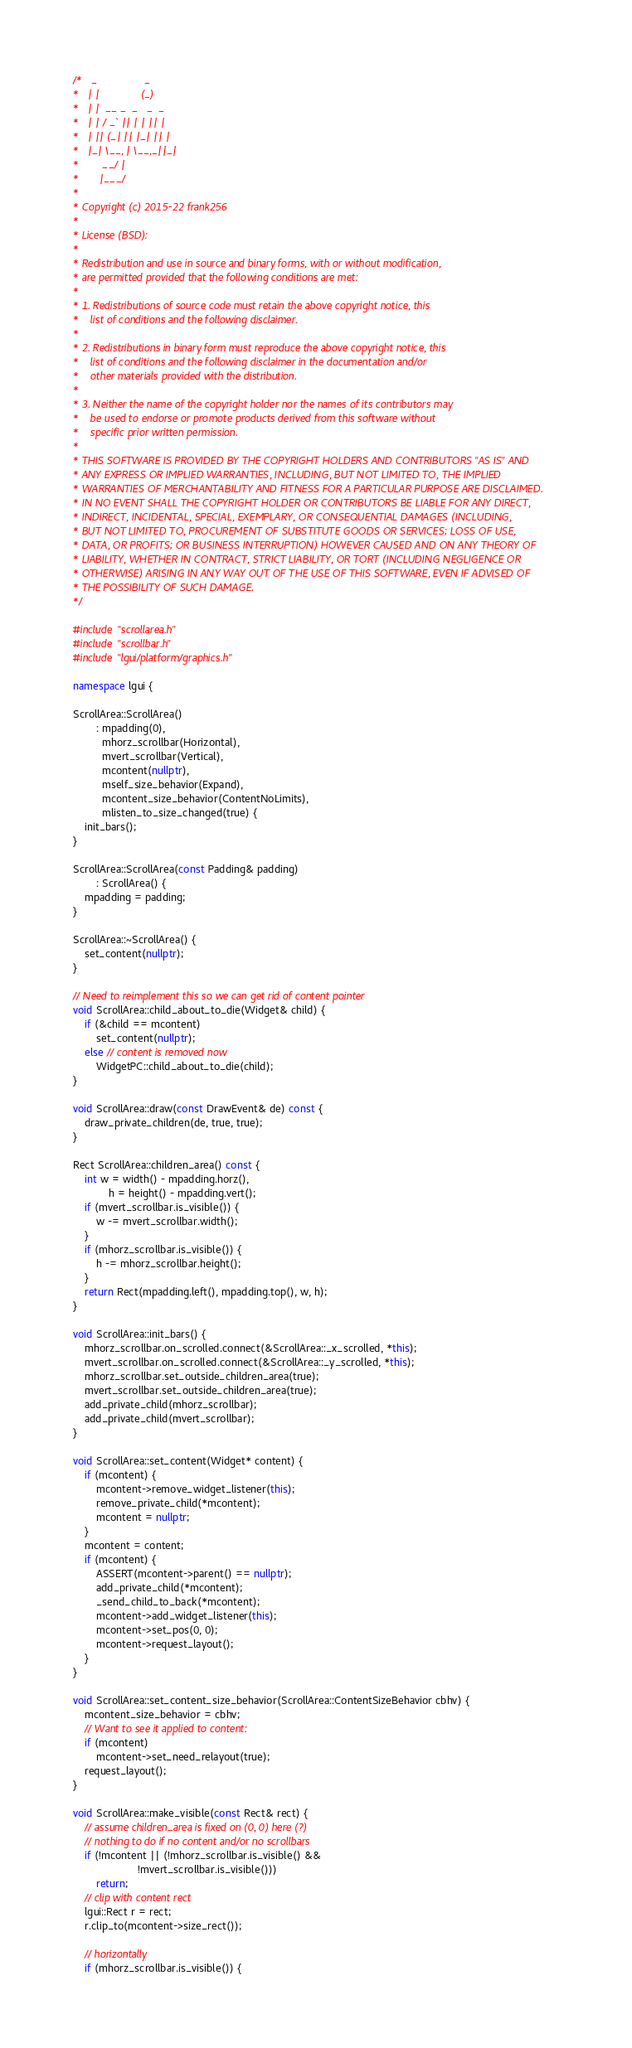<code> <loc_0><loc_0><loc_500><loc_500><_C++_>/*   _                _
*   | |              (_)
*   | |  __ _  _   _  _
*   | | / _` || | | || |
*   | || (_| || |_| || |
*   |_| \__, | \__,_||_|
*        __/ |
*       |___/
*
* Copyright (c) 2015-22 frank256
*
* License (BSD):
*
* Redistribution and use in source and binary forms, with or without modification,
* are permitted provided that the following conditions are met:
*
* 1. Redistributions of source code must retain the above copyright notice, this
*    list of conditions and the following disclaimer.
*
* 2. Redistributions in binary form must reproduce the above copyright notice, this
*    list of conditions and the following disclaimer in the documentation and/or
*    other materials provided with the distribution.
*
* 3. Neither the name of the copyright holder nor the names of its contributors may
*    be used to endorse or promote products derived from this software without
*    specific prior written permission.
*
* THIS SOFTWARE IS PROVIDED BY THE COPYRIGHT HOLDERS AND CONTRIBUTORS "AS IS" AND
* ANY EXPRESS OR IMPLIED WARRANTIES, INCLUDING, BUT NOT LIMITED TO, THE IMPLIED
* WARRANTIES OF MERCHANTABILITY AND FITNESS FOR A PARTICULAR PURPOSE ARE DISCLAIMED.
* IN NO EVENT SHALL THE COPYRIGHT HOLDER OR CONTRIBUTORS BE LIABLE FOR ANY DIRECT,
* INDIRECT, INCIDENTAL, SPECIAL, EXEMPLARY, OR CONSEQUENTIAL DAMAGES (INCLUDING,
* BUT NOT LIMITED TO, PROCUREMENT OF SUBSTITUTE GOODS OR SERVICES; LOSS OF USE,
* DATA, OR PROFITS; OR BUSINESS INTERRUPTION) HOWEVER CAUSED AND ON ANY THEORY OF
* LIABILITY, WHETHER IN CONTRACT, STRICT LIABILITY, OR TORT (INCLUDING NEGLIGENCE OR
* OTHERWISE) ARISING IN ANY WAY OUT OF THE USE OF THIS SOFTWARE, EVEN IF ADVISED OF
* THE POSSIBILITY OF SUCH DAMAGE.
*/

#include "scrollarea.h"
#include "scrollbar.h"
#include "lgui/platform/graphics.h"

namespace lgui {

ScrollArea::ScrollArea()
        : mpadding(0),
          mhorz_scrollbar(Horizontal),
          mvert_scrollbar(Vertical),
          mcontent(nullptr),
          mself_size_behavior(Expand),
          mcontent_size_behavior(ContentNoLimits),
          mlisten_to_size_changed(true) {
    init_bars();
}

ScrollArea::ScrollArea(const Padding& padding)
        : ScrollArea() {
    mpadding = padding;
}

ScrollArea::~ScrollArea() {
    set_content(nullptr);
}

// Need to reimplement this so we can get rid of content pointer
void ScrollArea::child_about_to_die(Widget& child) {
    if (&child == mcontent)
        set_content(nullptr);
    else // content is removed now
        WidgetPC::child_about_to_die(child);
}

void ScrollArea::draw(const DrawEvent& de) const {
    draw_private_children(de, true, true);
}

Rect ScrollArea::children_area() const {
    int w = width() - mpadding.horz(),
            h = height() - mpadding.vert();
    if (mvert_scrollbar.is_visible()) {
        w -= mvert_scrollbar.width();
    }
    if (mhorz_scrollbar.is_visible()) {
        h -= mhorz_scrollbar.height();
    }
    return Rect(mpadding.left(), mpadding.top(), w, h);
}

void ScrollArea::init_bars() {
    mhorz_scrollbar.on_scrolled.connect(&ScrollArea::_x_scrolled, *this);
    mvert_scrollbar.on_scrolled.connect(&ScrollArea::_y_scrolled, *this);
    mhorz_scrollbar.set_outside_children_area(true);
    mvert_scrollbar.set_outside_children_area(true);
    add_private_child(mhorz_scrollbar);
    add_private_child(mvert_scrollbar);
}

void ScrollArea::set_content(Widget* content) {
    if (mcontent) {
        mcontent->remove_widget_listener(this);
        remove_private_child(*mcontent);
        mcontent = nullptr;
    }
    mcontent = content;
    if (mcontent) {
        ASSERT(mcontent->parent() == nullptr);
        add_private_child(*mcontent);
        _send_child_to_back(*mcontent);
        mcontent->add_widget_listener(this);
        mcontent->set_pos(0, 0);
        mcontent->request_layout();
    }
}

void ScrollArea::set_content_size_behavior(ScrollArea::ContentSizeBehavior cbhv) {
    mcontent_size_behavior = cbhv;
    // Want to see it applied to content:
    if (mcontent)
        mcontent->set_need_relayout(true);
    request_layout();
}

void ScrollArea::make_visible(const Rect& rect) {
    // assume children_area is fixed on (0, 0) here (?)
    // nothing to do if no content and/or no scrollbars
    if (!mcontent || (!mhorz_scrollbar.is_visible() &&
                      !mvert_scrollbar.is_visible()))
        return;
    // clip with content rect
    lgui::Rect r = rect;
    r.clip_to(mcontent->size_rect());

    // horizontally
    if (mhorz_scrollbar.is_visible()) {</code> 